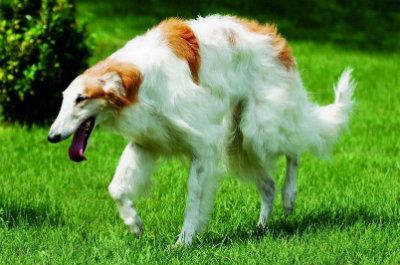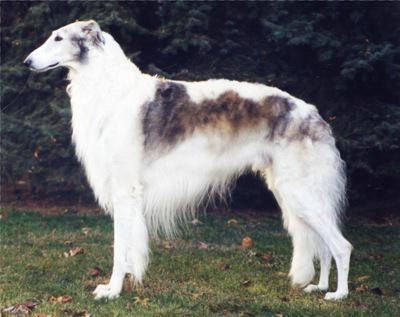The first image is the image on the left, the second image is the image on the right. Examine the images to the left and right. Is the description "An image shows exactly two hounds, which face one another." accurate? Answer yes or no. No. The first image is the image on the left, the second image is the image on the right. Analyze the images presented: Is the assertion "One of the pictures contains two dogs." valid? Answer yes or no. No. 